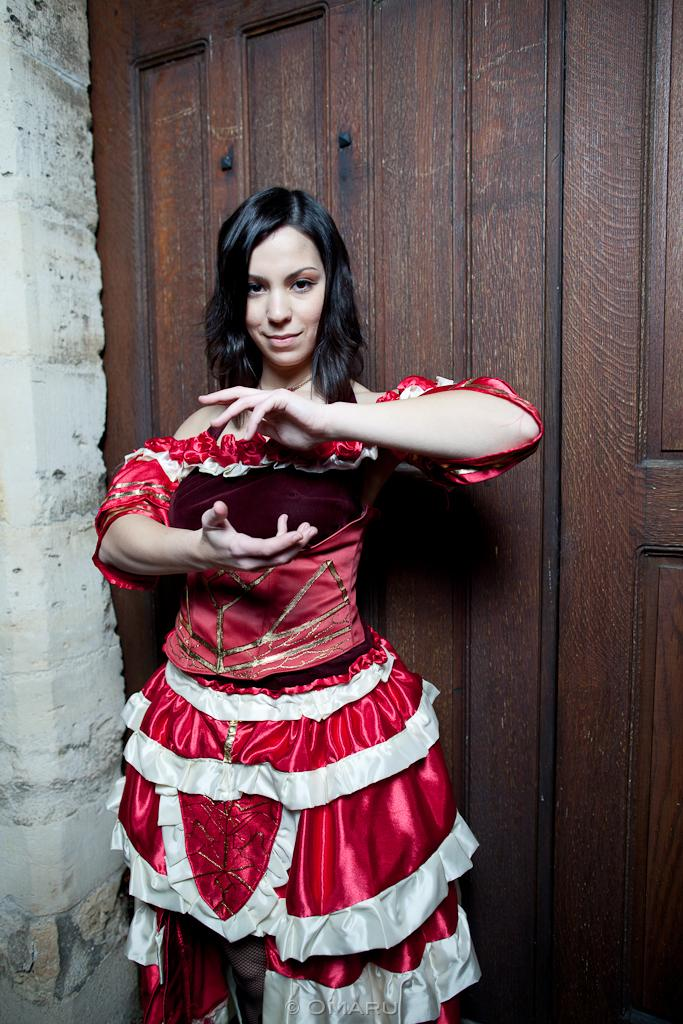Who is the main subject in the image? There is a lady standing in the center of the image. What can be seen in the background of the image? There is a wall and a door in the background of the image. Is there any text present in the image? Yes, there is some text at the bottom of the image. What type of credit can be seen being offered in the image? There is no credit or financial information present in the image; it features a lady standing in front of a wall and door with some text at the bottom. 